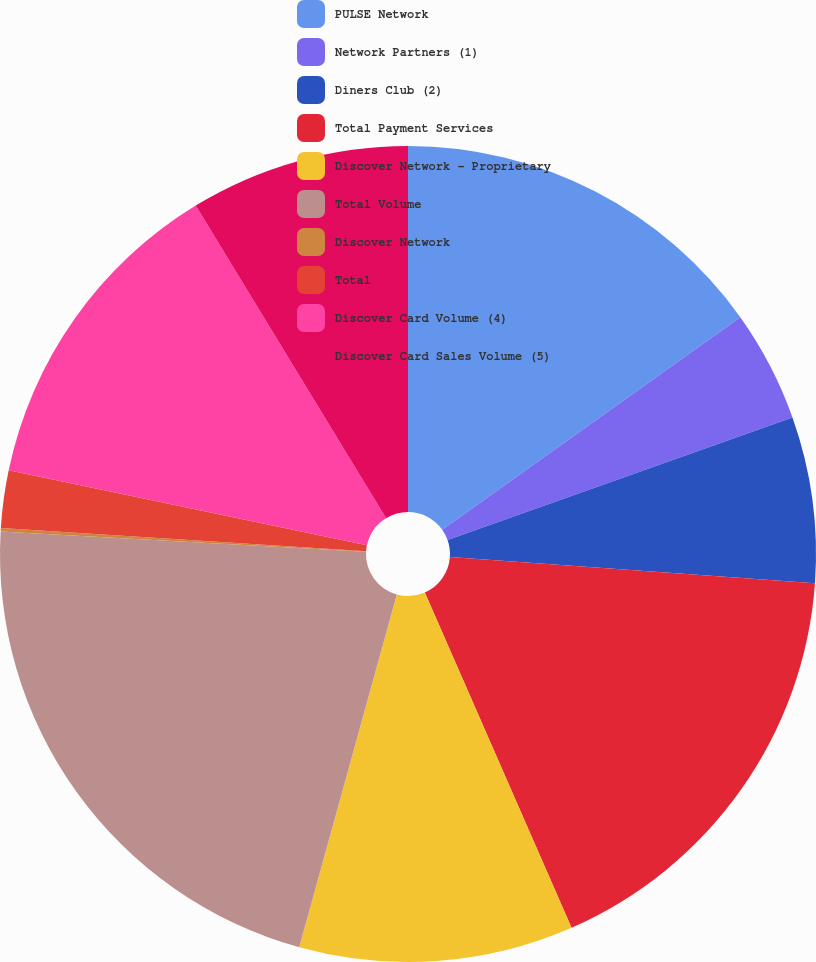<chart> <loc_0><loc_0><loc_500><loc_500><pie_chart><fcel>PULSE Network<fcel>Network Partners (1)<fcel>Diners Club (2)<fcel>Total Payment Services<fcel>Discover Network - Proprietary<fcel>Total Volume<fcel>Discover Network<fcel>Total<fcel>Discover Card Volume (4)<fcel>Discover Card Sales Volume (5)<nl><fcel>15.15%<fcel>4.42%<fcel>6.57%<fcel>17.3%<fcel>10.86%<fcel>21.59%<fcel>0.13%<fcel>2.28%<fcel>13.0%<fcel>8.71%<nl></chart> 